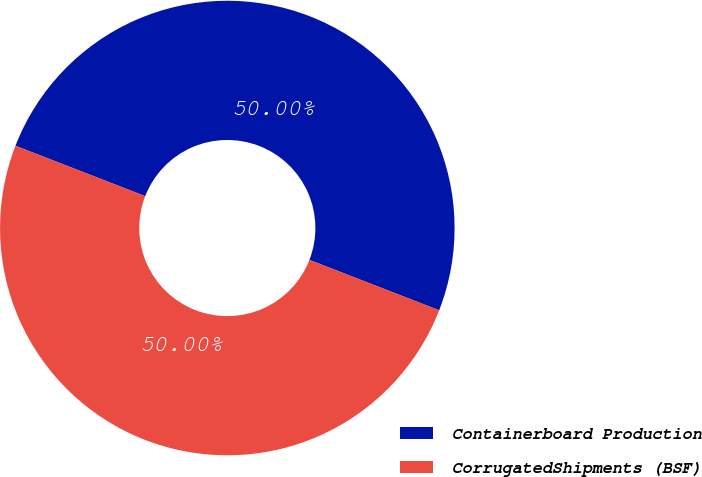<chart> <loc_0><loc_0><loc_500><loc_500><pie_chart><fcel>Containerboard Production<fcel>CorrugatedShipments (BSF)<nl><fcel>50.0%<fcel>50.0%<nl></chart> 